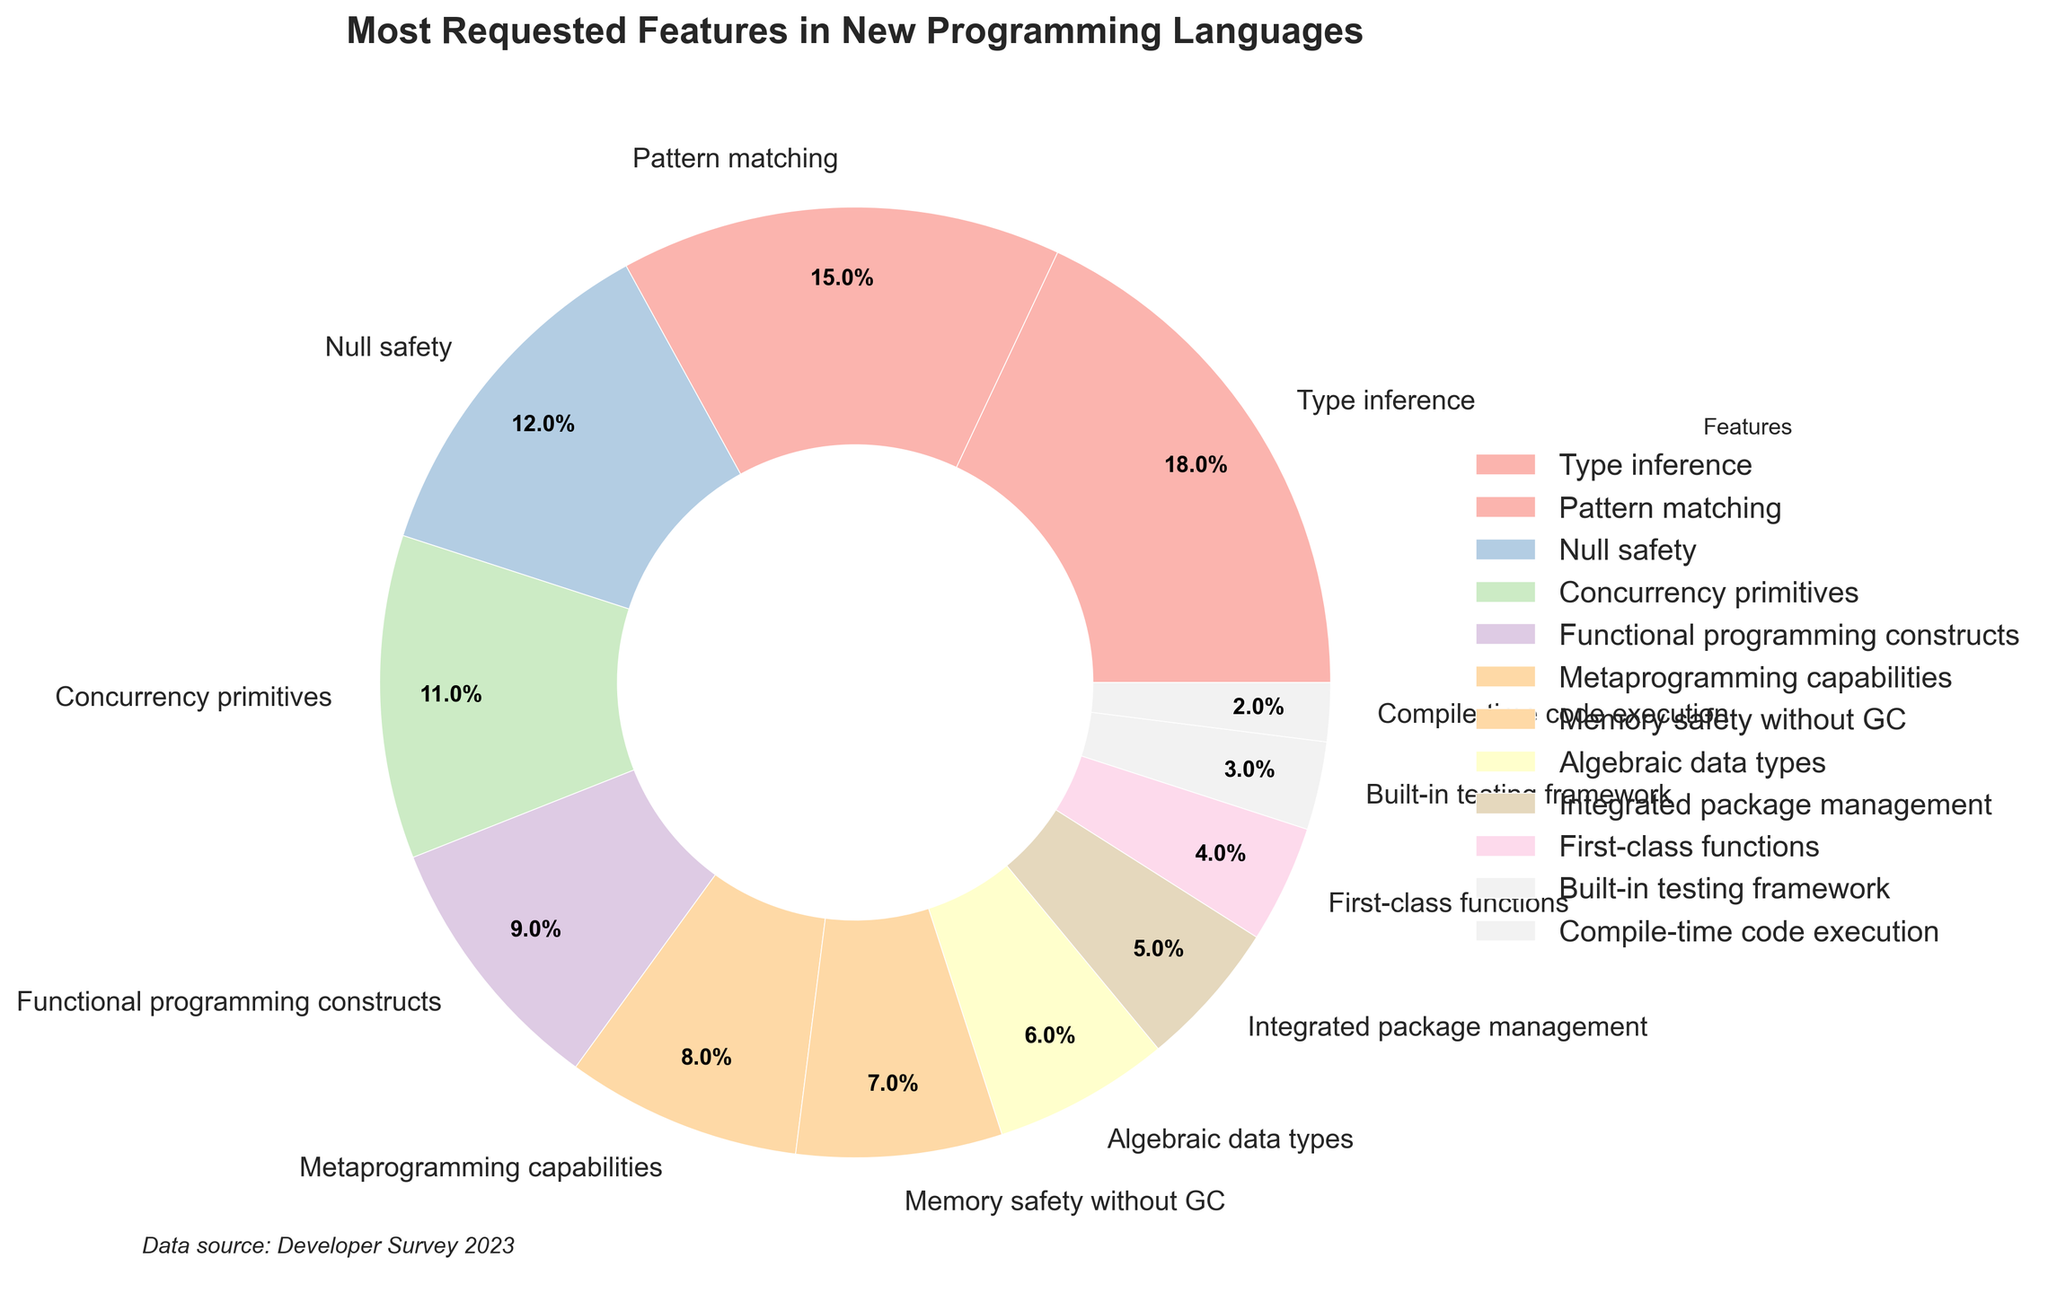What is the most requested feature according to the pie chart? The feature with the largest percentage in the pie chart will be the most requested one. The chart shows that 'Type inference' has the highest percentage of 18%.
Answer: Type inference Which two features together make up more than 30% of the requests? Summing the percentages of different features, 'Type inference' (18%) and 'Pattern matching' (15%) together make up 33%, which is more than 30%.
Answer: Type inference and Pattern matching Which feature is requested more: Null safety or Concurrency primitives? By examining the chart, we can see that 'Null safety' has a percentage of 12%, while 'Concurrency primitives' has 11%. Therefore, 'Null safety' is requested more.
Answer: Null safety How much more popular is Type inference compared to Integrated package management? From the chart, calculate the difference between 'Type inference' (18%) and 'Integrated package management' (5%). This results in a difference of 13%.
Answer: 13% What is the combined percentage of features related to safety (Null safety and Memory safety without GC)? Add the percentages of 'Null safety' (12%) and 'Memory safety without GC' (7%). The combined percentage is 19%.
Answer: 19% Which feature has the smallest percentage of requests? The smallest percentage on the chart corresponds to 'Compile-time code execution' with 2%.
Answer: Compile-time code execution If you combine the requests for Functional programming constructs and First-class functions, what is the total percentage? Adding the percentages of 'Functional programming constructs' (9%) and 'First-class functions' (4%) results in a total of 13%.
Answer: 13% Do Metaprogramming capabilities or Built-in testing framework have a higher request percentage? Comparing the percentages, 'Metaprogramming capabilities' (8%) have a higher request percentage than 'Built-in testing framework' (3%).
Answer: Metaprogramming capabilities How much more requested are features related to programming constructs (Type inference, Pattern matching, Functional programming constructs) compared to testing (Built-in testing framework)? Sum the percentages of 'Type inference' (18%), 'Pattern matching' (15%), and 'Functional programming constructs' (9%) to get 42%. The percentage for 'Built-in testing framework' is 3%. The difference is 42% - 3% = 39%.
Answer: 39% Which color represents the feature with the third highest request percentage? The feature with the third-highest percentage is 'Null safety' (12%). In the pie chart, the third feature is usually the third color used. If a pastel color scheme is used, identify the respective color visually.
Answer: [Description of the color, e.g., "light pink"] 